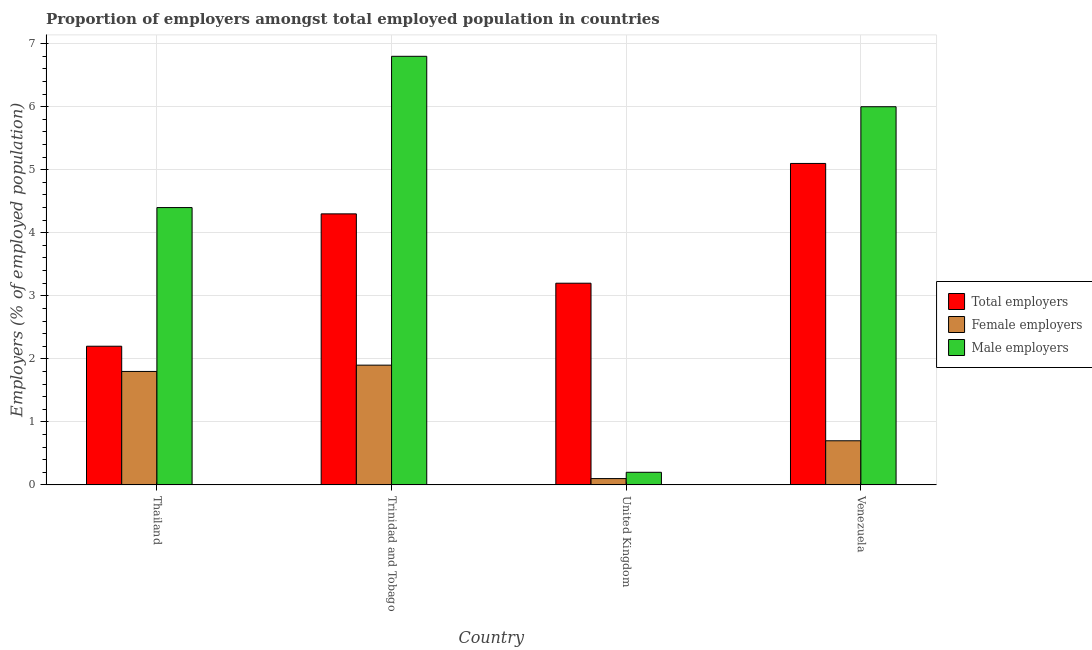How many different coloured bars are there?
Offer a very short reply. 3. Are the number of bars per tick equal to the number of legend labels?
Ensure brevity in your answer.  Yes. Are the number of bars on each tick of the X-axis equal?
Ensure brevity in your answer.  Yes. What is the label of the 1st group of bars from the left?
Provide a succinct answer. Thailand. In how many cases, is the number of bars for a given country not equal to the number of legend labels?
Provide a short and direct response. 0. What is the percentage of female employers in Trinidad and Tobago?
Offer a terse response. 1.9. Across all countries, what is the maximum percentage of total employers?
Offer a terse response. 5.1. Across all countries, what is the minimum percentage of male employers?
Give a very brief answer. 0.2. In which country was the percentage of male employers maximum?
Give a very brief answer. Trinidad and Tobago. In which country was the percentage of male employers minimum?
Ensure brevity in your answer.  United Kingdom. What is the total percentage of male employers in the graph?
Ensure brevity in your answer.  17.4. What is the difference between the percentage of male employers in Thailand and that in Trinidad and Tobago?
Give a very brief answer. -2.4. What is the difference between the percentage of total employers in United Kingdom and the percentage of female employers in Thailand?
Your response must be concise. 1.4. What is the average percentage of male employers per country?
Provide a succinct answer. 4.35. What is the difference between the percentage of female employers and percentage of male employers in Thailand?
Your answer should be very brief. -2.6. In how many countries, is the percentage of male employers greater than 0.8 %?
Your response must be concise. 3. What is the ratio of the percentage of male employers in Thailand to that in Venezuela?
Make the answer very short. 0.73. Is the percentage of total employers in Thailand less than that in Venezuela?
Make the answer very short. Yes. What is the difference between the highest and the second highest percentage of male employers?
Offer a very short reply. 0.8. What is the difference between the highest and the lowest percentage of female employers?
Keep it short and to the point. 1.8. In how many countries, is the percentage of total employers greater than the average percentage of total employers taken over all countries?
Offer a terse response. 2. What does the 1st bar from the left in Trinidad and Tobago represents?
Your answer should be compact. Total employers. What does the 2nd bar from the right in Thailand represents?
Your answer should be very brief. Female employers. How many bars are there?
Provide a succinct answer. 12. How many countries are there in the graph?
Your answer should be compact. 4. What is the difference between two consecutive major ticks on the Y-axis?
Provide a short and direct response. 1. Are the values on the major ticks of Y-axis written in scientific E-notation?
Offer a terse response. No. Where does the legend appear in the graph?
Provide a short and direct response. Center right. How many legend labels are there?
Keep it short and to the point. 3. How are the legend labels stacked?
Your answer should be very brief. Vertical. What is the title of the graph?
Offer a very short reply. Proportion of employers amongst total employed population in countries. What is the label or title of the Y-axis?
Offer a terse response. Employers (% of employed population). What is the Employers (% of employed population) of Total employers in Thailand?
Make the answer very short. 2.2. What is the Employers (% of employed population) in Female employers in Thailand?
Your answer should be very brief. 1.8. What is the Employers (% of employed population) in Male employers in Thailand?
Offer a terse response. 4.4. What is the Employers (% of employed population) of Total employers in Trinidad and Tobago?
Your response must be concise. 4.3. What is the Employers (% of employed population) of Female employers in Trinidad and Tobago?
Your answer should be compact. 1.9. What is the Employers (% of employed population) in Male employers in Trinidad and Tobago?
Your response must be concise. 6.8. What is the Employers (% of employed population) of Total employers in United Kingdom?
Offer a terse response. 3.2. What is the Employers (% of employed population) in Female employers in United Kingdom?
Give a very brief answer. 0.1. What is the Employers (% of employed population) of Male employers in United Kingdom?
Keep it short and to the point. 0.2. What is the Employers (% of employed population) in Total employers in Venezuela?
Offer a very short reply. 5.1. What is the Employers (% of employed population) in Female employers in Venezuela?
Your answer should be very brief. 0.7. Across all countries, what is the maximum Employers (% of employed population) in Total employers?
Give a very brief answer. 5.1. Across all countries, what is the maximum Employers (% of employed population) in Female employers?
Make the answer very short. 1.9. Across all countries, what is the maximum Employers (% of employed population) of Male employers?
Offer a terse response. 6.8. Across all countries, what is the minimum Employers (% of employed population) in Total employers?
Provide a short and direct response. 2.2. Across all countries, what is the minimum Employers (% of employed population) of Female employers?
Offer a very short reply. 0.1. Across all countries, what is the minimum Employers (% of employed population) in Male employers?
Keep it short and to the point. 0.2. What is the total Employers (% of employed population) of Female employers in the graph?
Offer a very short reply. 4.5. What is the difference between the Employers (% of employed population) in Male employers in Thailand and that in Trinidad and Tobago?
Your response must be concise. -2.4. What is the difference between the Employers (% of employed population) in Female employers in Thailand and that in United Kingdom?
Your answer should be compact. 1.7. What is the difference between the Employers (% of employed population) of Male employers in Thailand and that in United Kingdom?
Ensure brevity in your answer.  4.2. What is the difference between the Employers (% of employed population) of Total employers in Thailand and that in Venezuela?
Your answer should be very brief. -2.9. What is the difference between the Employers (% of employed population) of Male employers in Thailand and that in Venezuela?
Give a very brief answer. -1.6. What is the difference between the Employers (% of employed population) of Female employers in Trinidad and Tobago and that in United Kingdom?
Offer a very short reply. 1.8. What is the difference between the Employers (% of employed population) in Total employers in Trinidad and Tobago and that in Venezuela?
Give a very brief answer. -0.8. What is the difference between the Employers (% of employed population) of Male employers in Trinidad and Tobago and that in Venezuela?
Make the answer very short. 0.8. What is the difference between the Employers (% of employed population) in Total employers in United Kingdom and that in Venezuela?
Make the answer very short. -1.9. What is the difference between the Employers (% of employed population) in Total employers in Thailand and the Employers (% of employed population) in Female employers in Trinidad and Tobago?
Provide a short and direct response. 0.3. What is the difference between the Employers (% of employed population) of Total employers in Thailand and the Employers (% of employed population) of Female employers in United Kingdom?
Give a very brief answer. 2.1. What is the difference between the Employers (% of employed population) in Total employers in Thailand and the Employers (% of employed population) in Female employers in Venezuela?
Your answer should be compact. 1.5. What is the difference between the Employers (% of employed population) in Total employers in Thailand and the Employers (% of employed population) in Male employers in Venezuela?
Offer a terse response. -3.8. What is the difference between the Employers (% of employed population) of Female employers in Thailand and the Employers (% of employed population) of Male employers in Venezuela?
Keep it short and to the point. -4.2. What is the difference between the Employers (% of employed population) of Total employers in Trinidad and Tobago and the Employers (% of employed population) of Male employers in United Kingdom?
Your answer should be compact. 4.1. What is the difference between the Employers (% of employed population) in Total employers in United Kingdom and the Employers (% of employed population) in Male employers in Venezuela?
Provide a succinct answer. -2.8. What is the average Employers (% of employed population) in Total employers per country?
Your answer should be very brief. 3.7. What is the average Employers (% of employed population) in Female employers per country?
Make the answer very short. 1.12. What is the average Employers (% of employed population) of Male employers per country?
Ensure brevity in your answer.  4.35. What is the difference between the Employers (% of employed population) of Total employers and Employers (% of employed population) of Female employers in Thailand?
Your answer should be compact. 0.4. What is the difference between the Employers (% of employed population) in Total employers and Employers (% of employed population) in Female employers in Trinidad and Tobago?
Offer a very short reply. 2.4. What is the difference between the Employers (% of employed population) in Total employers and Employers (% of employed population) in Male employers in Trinidad and Tobago?
Provide a short and direct response. -2.5. What is the difference between the Employers (% of employed population) of Female employers and Employers (% of employed population) of Male employers in Trinidad and Tobago?
Your response must be concise. -4.9. What is the difference between the Employers (% of employed population) in Total employers and Employers (% of employed population) in Female employers in United Kingdom?
Your answer should be very brief. 3.1. What is the ratio of the Employers (% of employed population) in Total employers in Thailand to that in Trinidad and Tobago?
Ensure brevity in your answer.  0.51. What is the ratio of the Employers (% of employed population) of Male employers in Thailand to that in Trinidad and Tobago?
Keep it short and to the point. 0.65. What is the ratio of the Employers (% of employed population) in Total employers in Thailand to that in United Kingdom?
Your answer should be very brief. 0.69. What is the ratio of the Employers (% of employed population) of Total employers in Thailand to that in Venezuela?
Your answer should be compact. 0.43. What is the ratio of the Employers (% of employed population) in Female employers in Thailand to that in Venezuela?
Ensure brevity in your answer.  2.57. What is the ratio of the Employers (% of employed population) of Male employers in Thailand to that in Venezuela?
Ensure brevity in your answer.  0.73. What is the ratio of the Employers (% of employed population) of Total employers in Trinidad and Tobago to that in United Kingdom?
Make the answer very short. 1.34. What is the ratio of the Employers (% of employed population) of Female employers in Trinidad and Tobago to that in United Kingdom?
Your response must be concise. 19. What is the ratio of the Employers (% of employed population) in Male employers in Trinidad and Tobago to that in United Kingdom?
Give a very brief answer. 34. What is the ratio of the Employers (% of employed population) in Total employers in Trinidad and Tobago to that in Venezuela?
Offer a very short reply. 0.84. What is the ratio of the Employers (% of employed population) in Female employers in Trinidad and Tobago to that in Venezuela?
Give a very brief answer. 2.71. What is the ratio of the Employers (% of employed population) of Male employers in Trinidad and Tobago to that in Venezuela?
Keep it short and to the point. 1.13. What is the ratio of the Employers (% of employed population) of Total employers in United Kingdom to that in Venezuela?
Keep it short and to the point. 0.63. What is the ratio of the Employers (% of employed population) in Female employers in United Kingdom to that in Venezuela?
Make the answer very short. 0.14. What is the ratio of the Employers (% of employed population) in Male employers in United Kingdom to that in Venezuela?
Give a very brief answer. 0.03. What is the difference between the highest and the second highest Employers (% of employed population) in Total employers?
Your answer should be compact. 0.8. What is the difference between the highest and the second highest Employers (% of employed population) in Male employers?
Provide a succinct answer. 0.8. What is the difference between the highest and the lowest Employers (% of employed population) of Total employers?
Your answer should be compact. 2.9. 